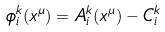<formula> <loc_0><loc_0><loc_500><loc_500>\phi _ { i } ^ { k } ( x ^ { \mu } ) = A _ { i } ^ { k } ( x ^ { \mu } ) - C _ { i } ^ { k }</formula> 